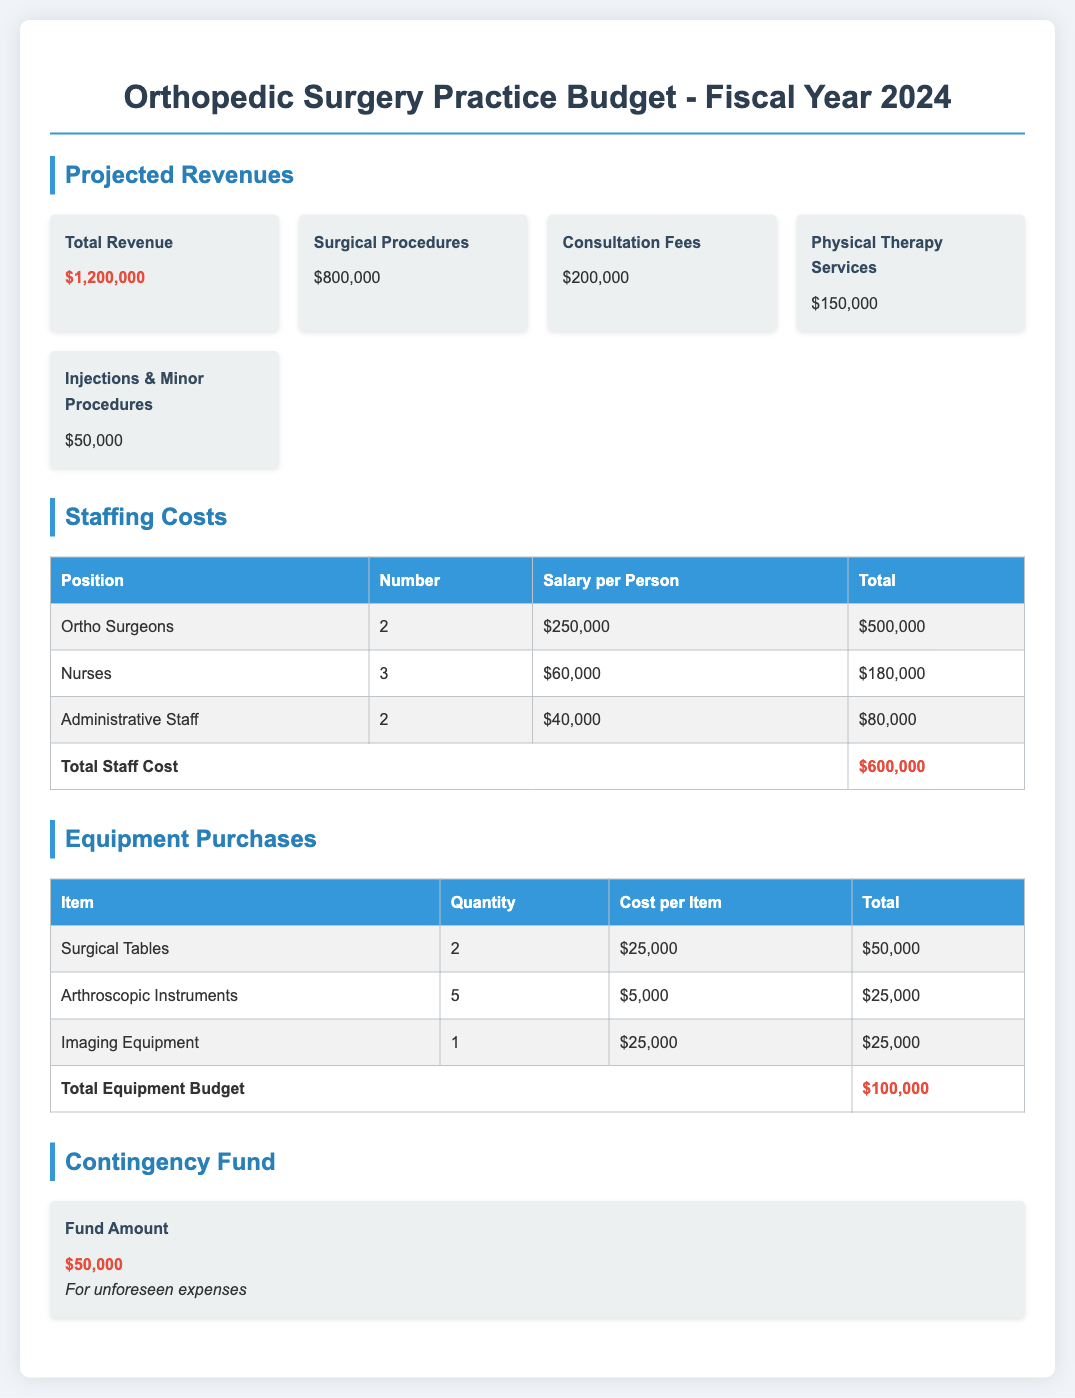what is the total revenue? The total revenue is stated at the top of the projected revenues section, which is $1,200,000.
Answer: $1,200,000 how much does the practice allocate for surgical tables? The budget lists the cost for surgical tables under equipment purchases, which totals $50,000.
Answer: $50,000 how many orthopedic surgeons are included in the staffing costs? The number of orthopedic surgeons is specified in the staffing costs table, which lists 2.
Answer: 2 what is the total staff cost? The total staff cost is calculated in the staffing costs table and is highlighted as $600,000.
Answer: $600,000 what is the contingency fund amount? The amount designated for the contingency fund is mentioned in the last section of the document as $50,000.
Answer: $50,000 how many nurses are part of the staffing plan? The staffing costs table indicates that there are 3 nurses included in the plan.
Answer: 3 what is the highlighted total for equipment purchases? The total for equipment purchases is the final amount noted in the equipment purchases table, which is $100,000.
Answer: $100,000 what are the projected revenues from consultation fees? The projected revenue from consultation fees is stated in the projected revenues section as $200,000.
Answer: $200,000 how many arthroscopic instruments does the budget plan to purchase? The equipment purchases table shows that the budget plans to purchase 5 arthroscopic instruments.
Answer: 5 